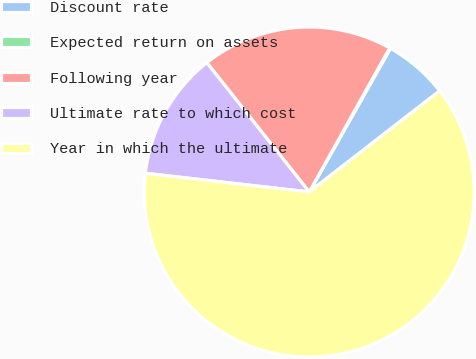Convert chart to OTSL. <chart><loc_0><loc_0><loc_500><loc_500><pie_chart><fcel>Discount rate<fcel>Expected return on assets<fcel>Following year<fcel>Ultimate rate to which cost<fcel>Year in which the ultimate<nl><fcel>6.31%<fcel>0.09%<fcel>18.76%<fcel>12.53%<fcel>62.3%<nl></chart> 